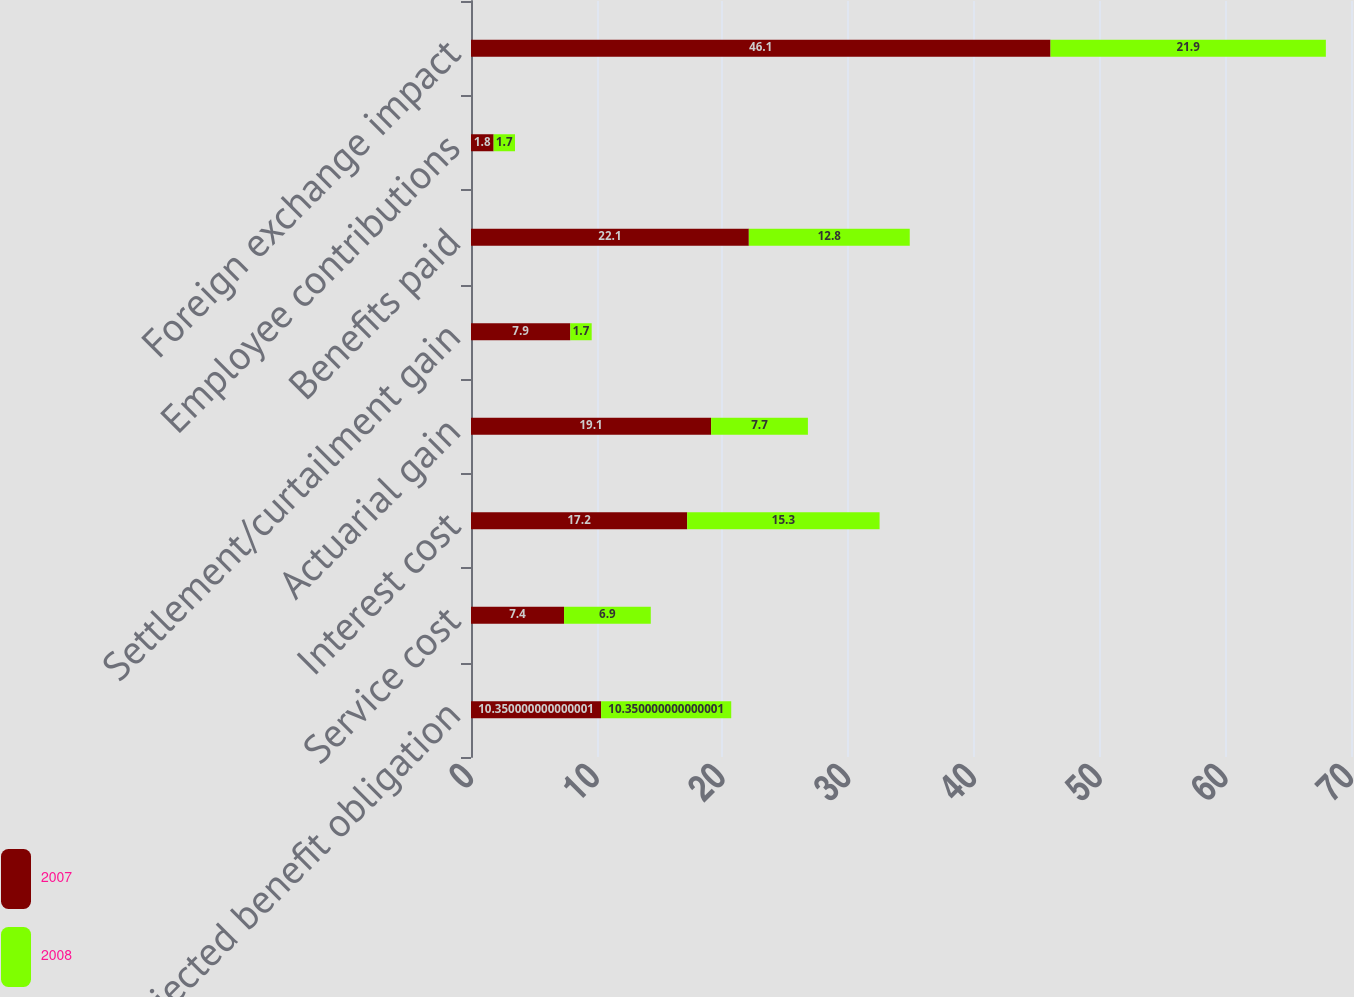<chart> <loc_0><loc_0><loc_500><loc_500><stacked_bar_chart><ecel><fcel>Projected benefit obligation<fcel>Service cost<fcel>Interest cost<fcel>Actuarial gain<fcel>Settlement/curtailment gain<fcel>Benefits paid<fcel>Employee contributions<fcel>Foreign exchange impact<nl><fcel>2007<fcel>10.35<fcel>7.4<fcel>17.2<fcel>19.1<fcel>7.9<fcel>22.1<fcel>1.8<fcel>46.1<nl><fcel>2008<fcel>10.35<fcel>6.9<fcel>15.3<fcel>7.7<fcel>1.7<fcel>12.8<fcel>1.7<fcel>21.9<nl></chart> 